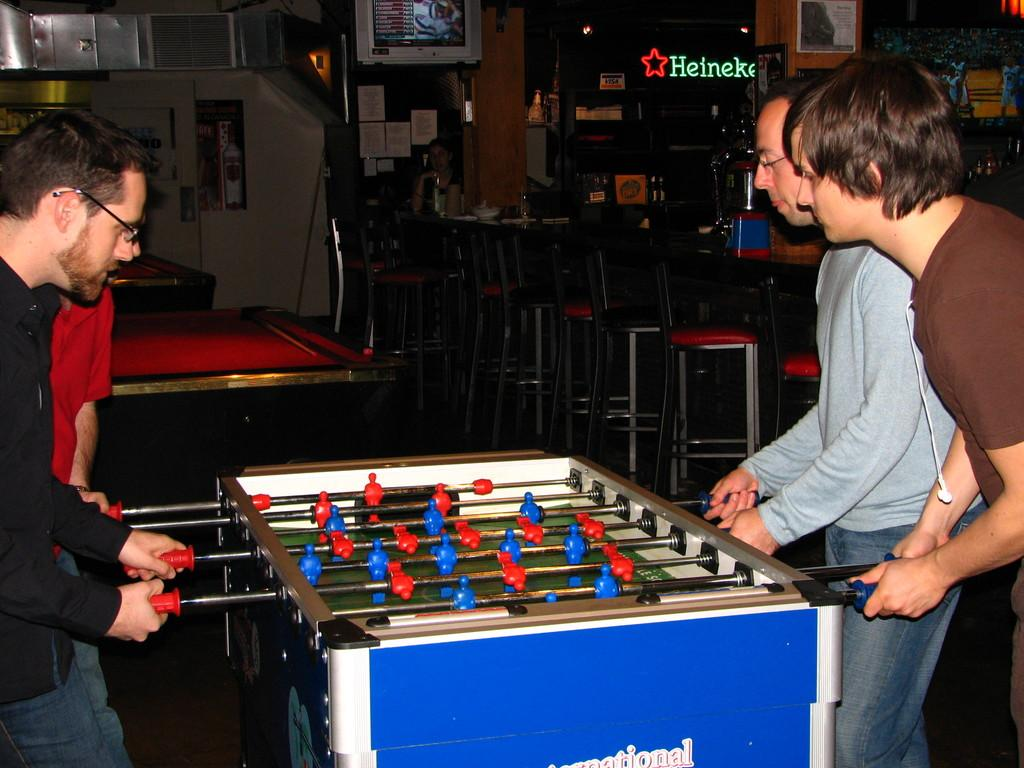What activity are the people in the image engaged in? The people in the image are playing Foosball. What type of furniture can be seen in the image? Chairs are visible in the image. How are the tables arranged in the image? Tables are arranged in the image. What type of water is being used to play Foosball in the image? There is no water present in the image; Foosball is played with a table and rods, not water. 